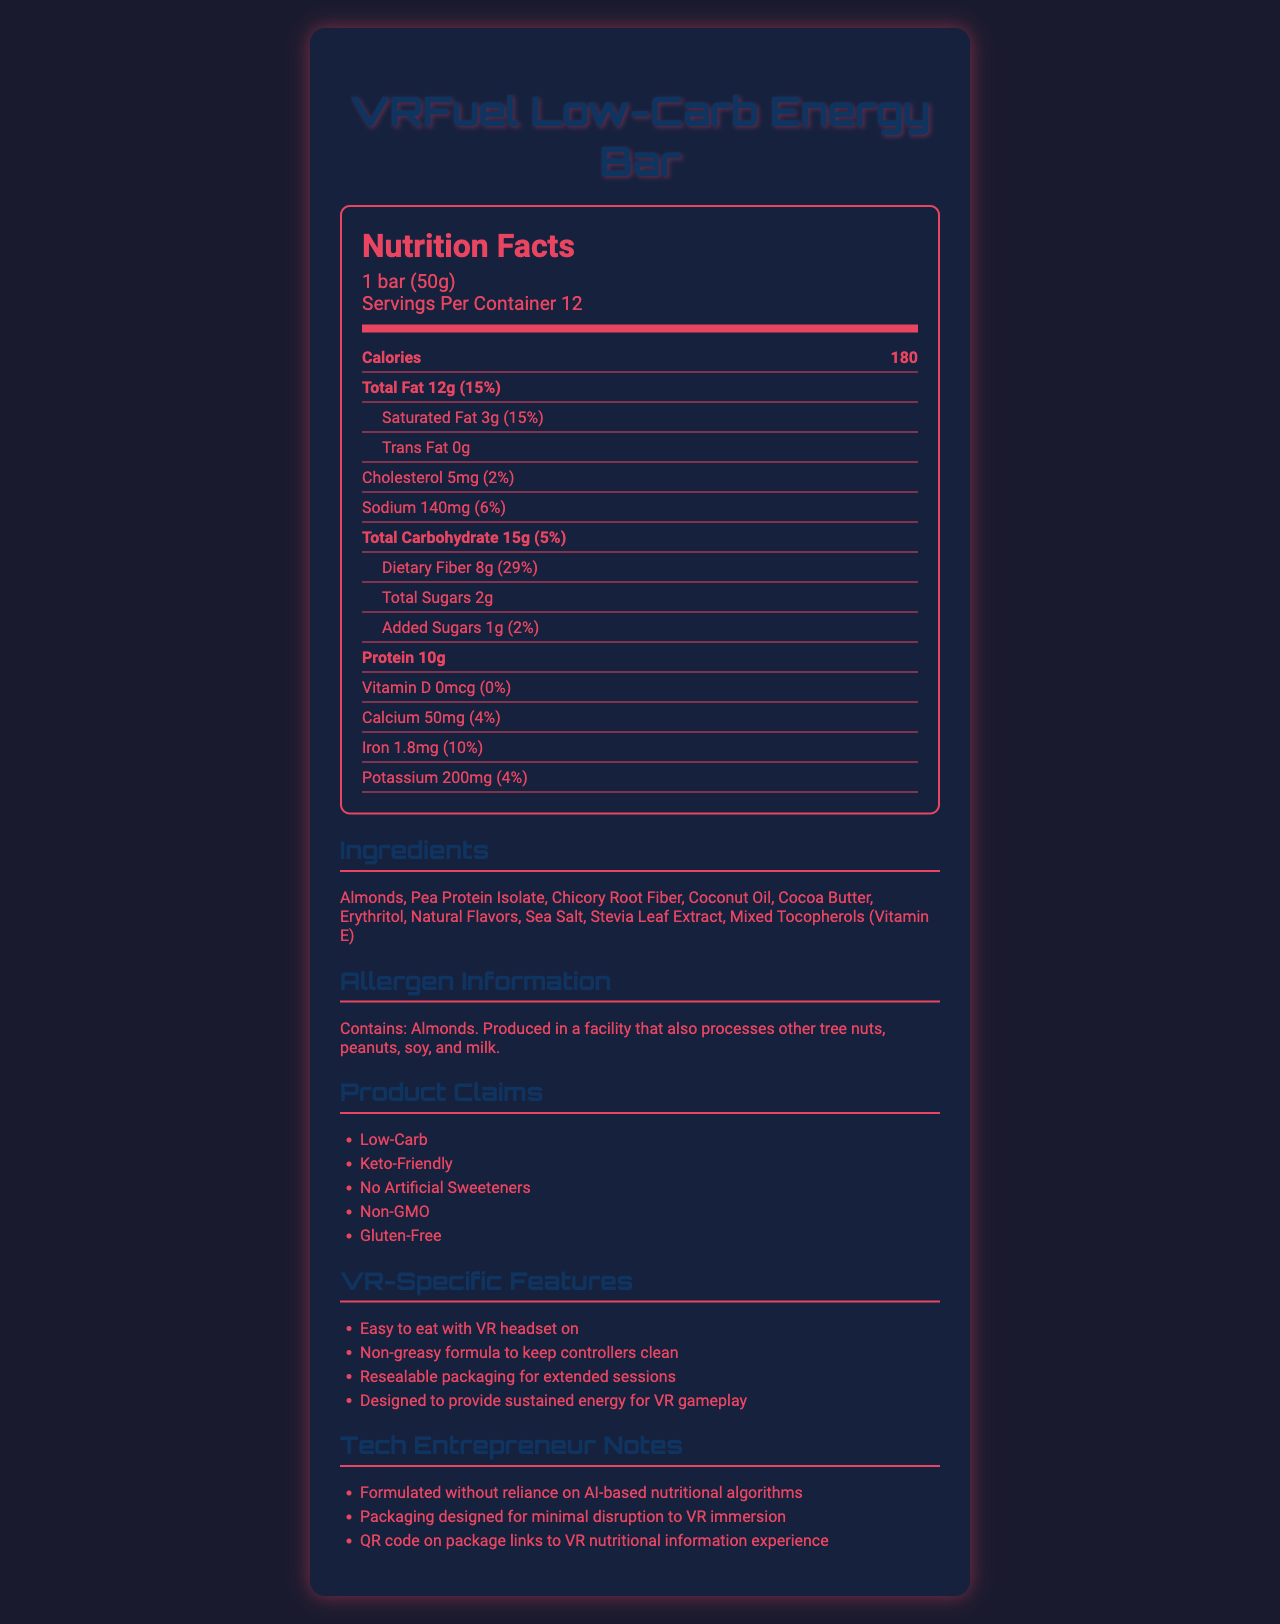what is the serving size? The serving size is explicitly stated in the document as "1 bar (50g)".
Answer: 1 bar (50g) how many servings are there per container? The document specifies "Servings Per Container 12".
Answer: 12 what is the total amount of calories per serving? The calories per serving are listed as 180 calories.
Answer: 180 calories how much saturated fat does the bar contain per serving? The document lists "Saturated Fat 3g".
Answer: 3g what is the dietary fiber content per serving, and its daily value percentage? The document states "Dietary Fiber 8g (29%)".
Answer: 8g, 29% how much protein is in one serving of the snack bar? The document lists the protein content as 10g.
Answer: 10g how much potassium is in the bar and what is its daily value percentage? The document indicates "Potassium 200mg (4%)".
Answer: 200mg, 4% which of the following ingredients is NOT listed on the document? A. Almonds B. Chocolate C. Sea Salt Chocolate is not listed in the document; Almonds and Sea Salt are listed.
Answer: B this snack bar is: A. High in Trans Fat B. Gluten-Free C. full of Artificial Sweeteners D. Non-GMO The document mentions the bar is "Gluten-Free".
Answer: B does the document mention any VR-specific features? The document lists several VR-specific features under "VR-Specific Features", such as "Easy to eat with VR headset on".
Answer: Yes summarize the main idea of the document. The main idea is presenting the VRFuel Low-Carb Energy Bar as a specialized product for VR users, outlining its nutritional information, special features, and ingredient details.
Answer: The document provides nutritional facts for the VRFuel Low-Carb Energy Bar, highlighting its low-carb content, VR-specific features, and key ingredients. It also includes allergen information, product claims, and notes for tech entrepreneurs focused on VR adaptability and user experience. is the VRFuel Low-Carb Energy Bar produced in a facility that also processes tree nuts? The allergen information section states that it is produced in a facility that processes tree nuts.
Answer: Yes can we determine if the bar is organic from the document? The document does not mention whether the ingredients are organic or not.
Answer: Not enough information 